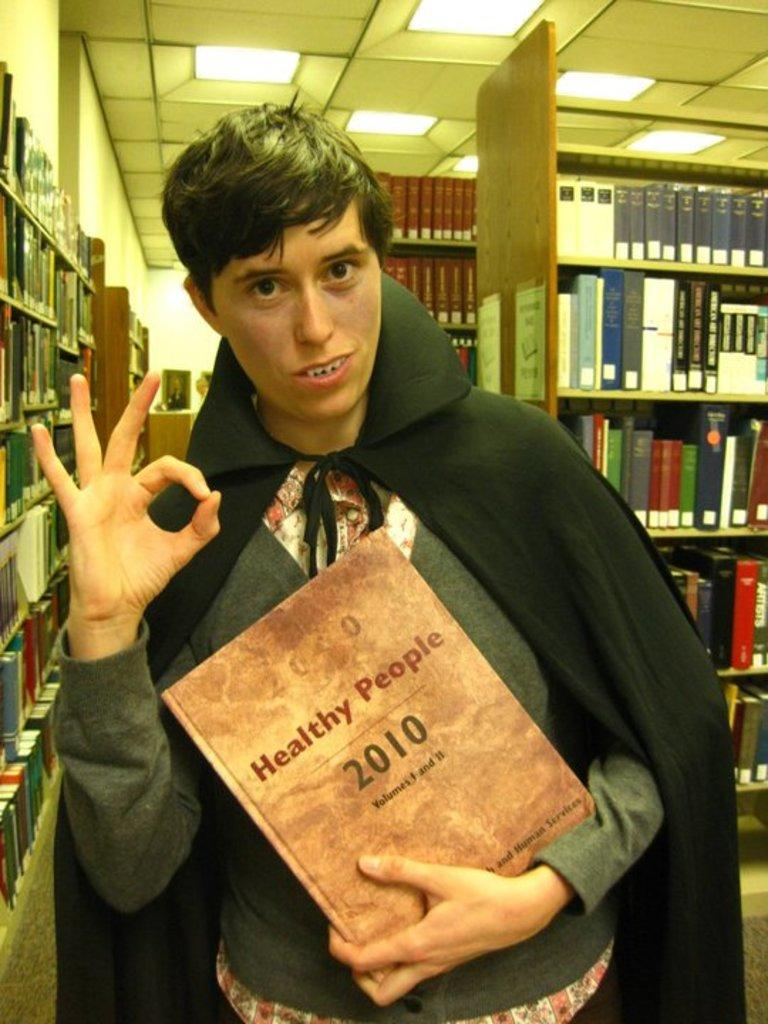<image>
Share a concise interpretation of the image provided. A boy in a black cape holding a book titled healthy people, 